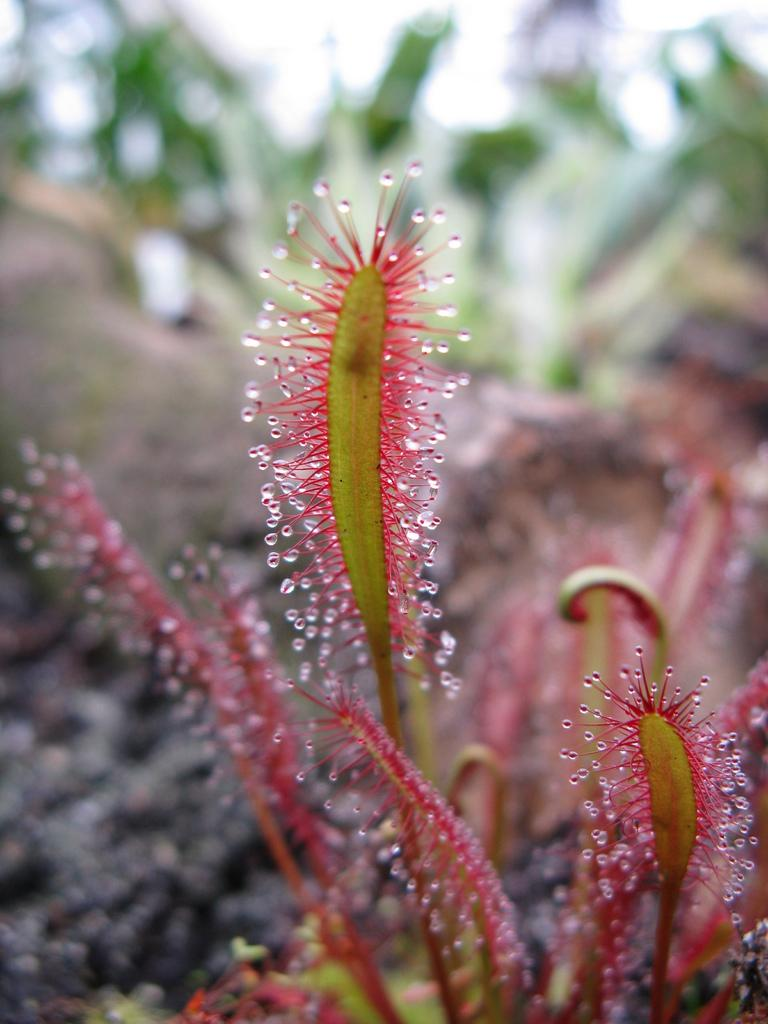What type of living organisms can be seen in the image? Plants can be seen in the image. Can you describe the background of the image? The background of the image is blurred. How many legs does the plant have in the image? Plants do not have legs, as they are stationary organisms. 